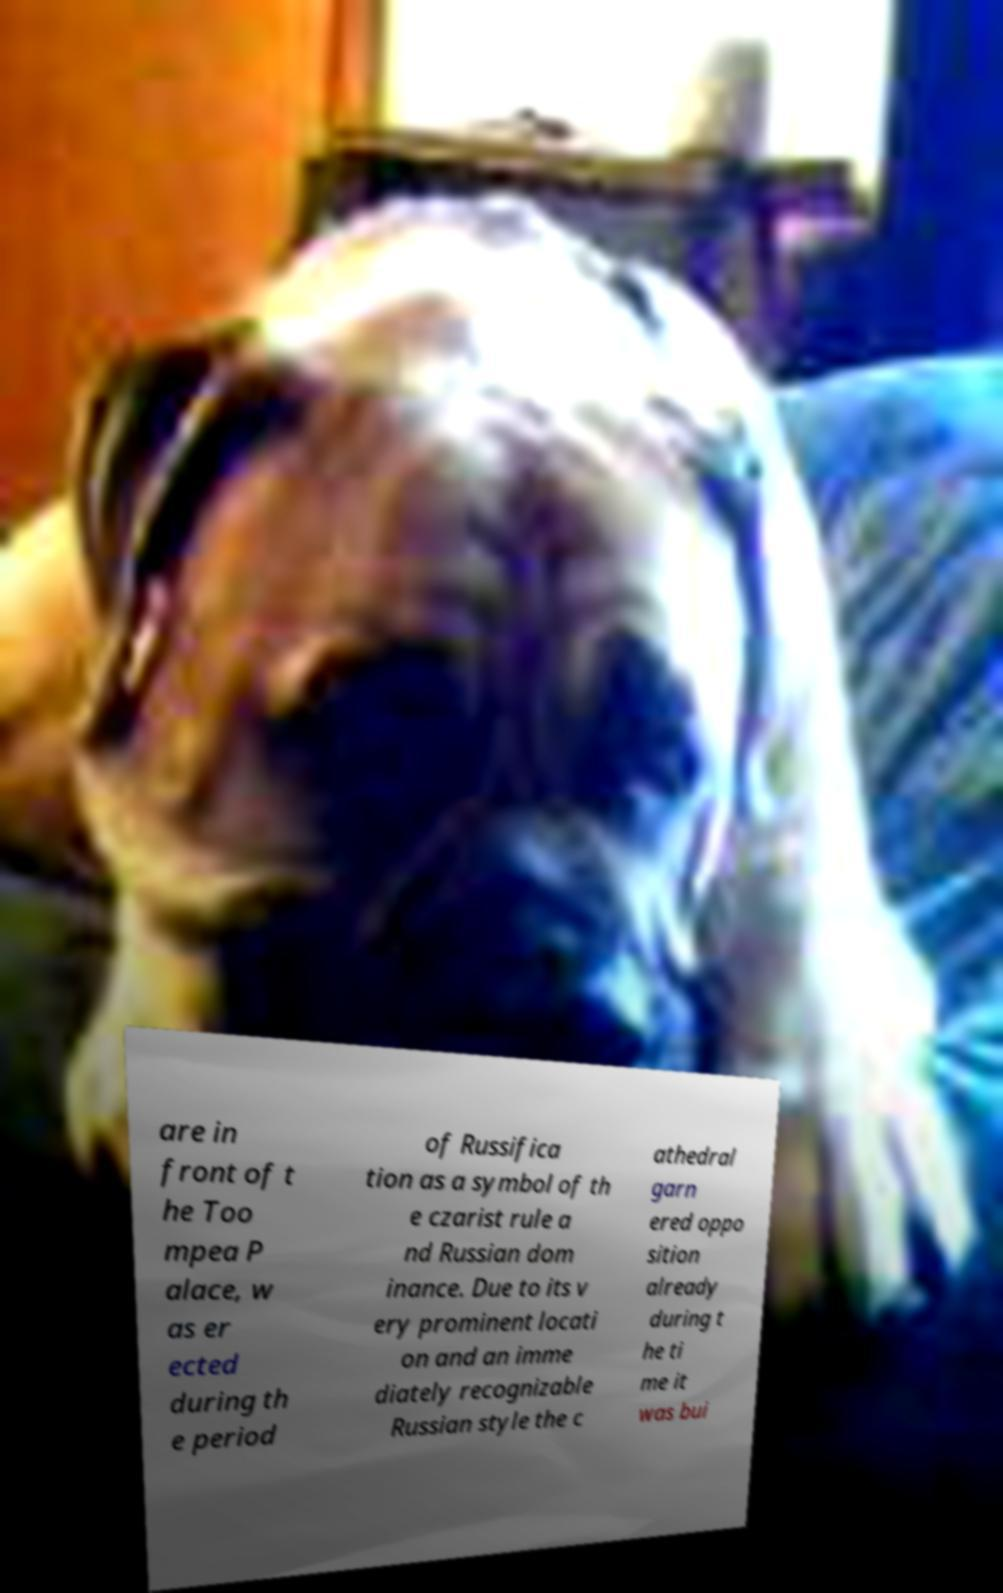Can you accurately transcribe the text from the provided image for me? are in front of t he Too mpea P alace, w as er ected during th e period of Russifica tion as a symbol of th e czarist rule a nd Russian dom inance. Due to its v ery prominent locati on and an imme diately recognizable Russian style the c athedral garn ered oppo sition already during t he ti me it was bui 